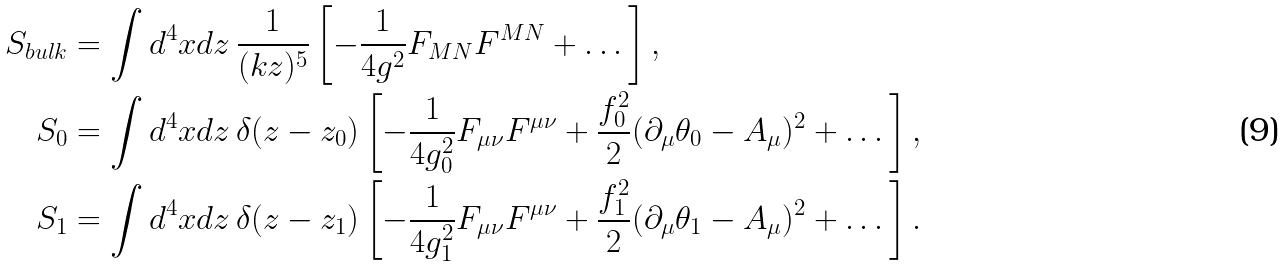<formula> <loc_0><loc_0><loc_500><loc_500>S _ { b u l k } & = \int d ^ { 4 } x d z \, \frac { 1 } { ( k z ) ^ { 5 } } \left [ - \frac { 1 } { 4 g ^ { 2 } } F _ { M N } F ^ { M N } + \dots \right ] , \\ S _ { 0 } & = \int d ^ { 4 } x d z \, \delta ( z - z _ { 0 } ) \left [ - \frac { 1 } { 4 g _ { 0 } ^ { 2 } } F _ { \mu \nu } F ^ { \mu \nu } + \frac { f _ { 0 } ^ { 2 } } { 2 } ( \partial _ { \mu } \theta _ { 0 } - A _ { \mu } ) ^ { 2 } + \dots \right ] , \\ S _ { 1 } & = \int d ^ { 4 } x d z \, \delta ( z - z _ { 1 } ) \left [ - \frac { 1 } { 4 g _ { 1 } ^ { 2 } } F _ { \mu \nu } F ^ { \mu \nu } + \frac { f _ { 1 } ^ { 2 } } { 2 } ( \partial _ { \mu } \theta _ { 1 } - A _ { \mu } ) ^ { 2 } + \dots \right ] .</formula> 